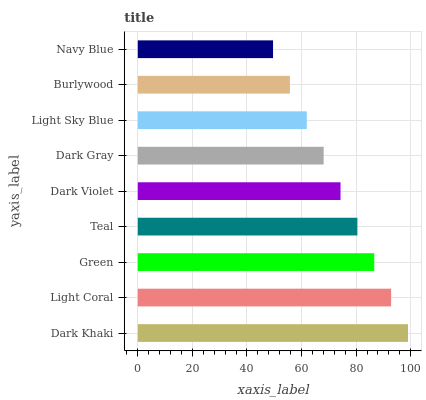Is Navy Blue the minimum?
Answer yes or no. Yes. Is Dark Khaki the maximum?
Answer yes or no. Yes. Is Light Coral the minimum?
Answer yes or no. No. Is Light Coral the maximum?
Answer yes or no. No. Is Dark Khaki greater than Light Coral?
Answer yes or no. Yes. Is Light Coral less than Dark Khaki?
Answer yes or no. Yes. Is Light Coral greater than Dark Khaki?
Answer yes or no. No. Is Dark Khaki less than Light Coral?
Answer yes or no. No. Is Dark Violet the high median?
Answer yes or no. Yes. Is Dark Violet the low median?
Answer yes or no. Yes. Is Green the high median?
Answer yes or no. No. Is Navy Blue the low median?
Answer yes or no. No. 